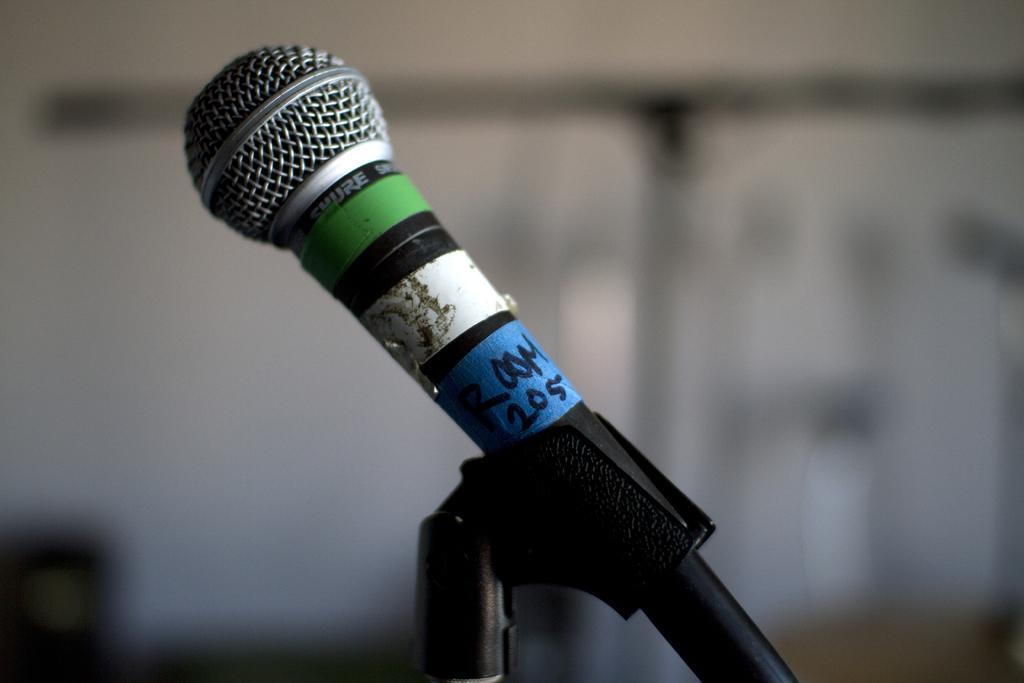Could you give a brief overview of what you see in this image? In the middle of this image, there is a microphone attached to a stand. And the background is blurred. 